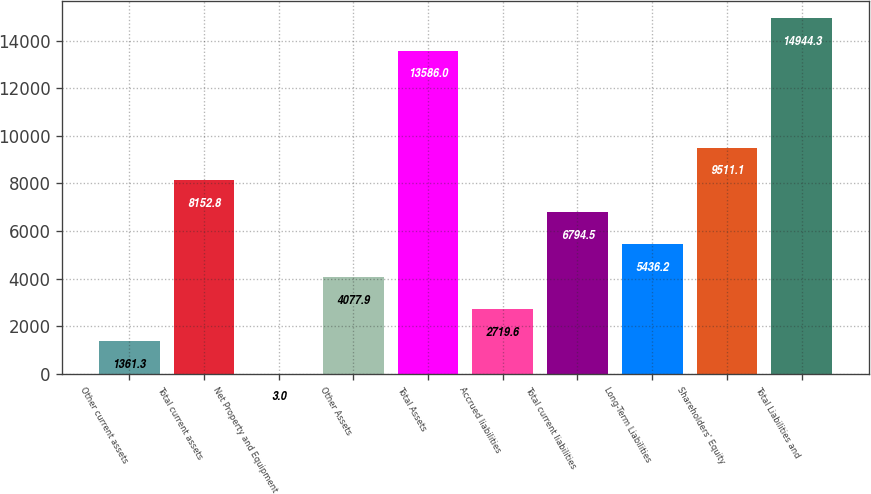Convert chart. <chart><loc_0><loc_0><loc_500><loc_500><bar_chart><fcel>Other current assets<fcel>Total current assets<fcel>Net Property and Equipment<fcel>Other Assets<fcel>Total Assets<fcel>Accrued liabilities<fcel>Total current liabilities<fcel>Long-Term Liabilities<fcel>Shareholders' Equity<fcel>Total Liabilities and<nl><fcel>1361.3<fcel>8152.8<fcel>3<fcel>4077.9<fcel>13586<fcel>2719.6<fcel>6794.5<fcel>5436.2<fcel>9511.1<fcel>14944.3<nl></chart> 